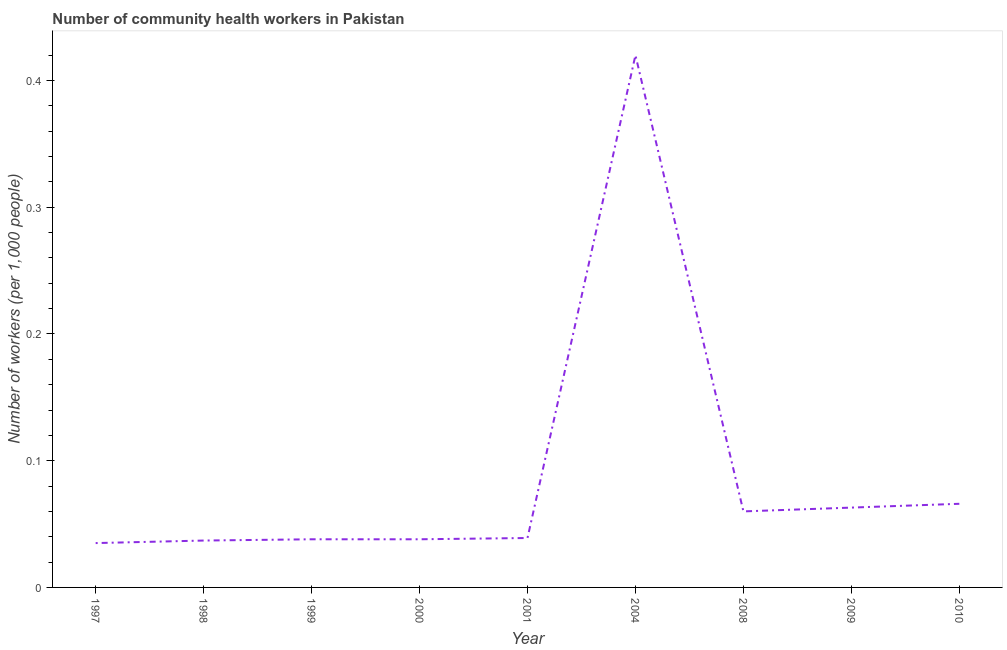What is the number of community health workers in 1998?
Provide a succinct answer. 0.04. Across all years, what is the maximum number of community health workers?
Your answer should be compact. 0.42. Across all years, what is the minimum number of community health workers?
Your answer should be very brief. 0.04. In which year was the number of community health workers minimum?
Your response must be concise. 1997. What is the sum of the number of community health workers?
Keep it short and to the point. 0.8. What is the difference between the number of community health workers in 2001 and 2004?
Make the answer very short. -0.38. What is the average number of community health workers per year?
Make the answer very short. 0.09. What is the median number of community health workers?
Your answer should be very brief. 0.04. Do a majority of the years between 1999 and 2008 (inclusive) have number of community health workers greater than 0.34 ?
Your response must be concise. No. What is the ratio of the number of community health workers in 1999 to that in 2009?
Your answer should be compact. 0.6. Is the number of community health workers in 2001 less than that in 2004?
Offer a terse response. Yes. What is the difference between the highest and the second highest number of community health workers?
Give a very brief answer. 0.35. What is the difference between the highest and the lowest number of community health workers?
Ensure brevity in your answer.  0.39. Does the number of community health workers monotonically increase over the years?
Your response must be concise. No. How many lines are there?
Provide a succinct answer. 1. What is the difference between two consecutive major ticks on the Y-axis?
Offer a very short reply. 0.1. What is the title of the graph?
Make the answer very short. Number of community health workers in Pakistan. What is the label or title of the Y-axis?
Ensure brevity in your answer.  Number of workers (per 1,0 people). What is the Number of workers (per 1,000 people) of 1997?
Offer a very short reply. 0.04. What is the Number of workers (per 1,000 people) in 1998?
Keep it short and to the point. 0.04. What is the Number of workers (per 1,000 people) in 1999?
Give a very brief answer. 0.04. What is the Number of workers (per 1,000 people) in 2000?
Your answer should be compact. 0.04. What is the Number of workers (per 1,000 people) in 2001?
Provide a short and direct response. 0.04. What is the Number of workers (per 1,000 people) in 2004?
Make the answer very short. 0.42. What is the Number of workers (per 1,000 people) of 2009?
Your response must be concise. 0.06. What is the Number of workers (per 1,000 people) of 2010?
Offer a very short reply. 0.07. What is the difference between the Number of workers (per 1,000 people) in 1997 and 1998?
Make the answer very short. -0. What is the difference between the Number of workers (per 1,000 people) in 1997 and 1999?
Give a very brief answer. -0. What is the difference between the Number of workers (per 1,000 people) in 1997 and 2000?
Provide a short and direct response. -0. What is the difference between the Number of workers (per 1,000 people) in 1997 and 2001?
Give a very brief answer. -0. What is the difference between the Number of workers (per 1,000 people) in 1997 and 2004?
Give a very brief answer. -0.39. What is the difference between the Number of workers (per 1,000 people) in 1997 and 2008?
Give a very brief answer. -0.03. What is the difference between the Number of workers (per 1,000 people) in 1997 and 2009?
Make the answer very short. -0.03. What is the difference between the Number of workers (per 1,000 people) in 1997 and 2010?
Keep it short and to the point. -0.03. What is the difference between the Number of workers (per 1,000 people) in 1998 and 1999?
Give a very brief answer. -0. What is the difference between the Number of workers (per 1,000 people) in 1998 and 2000?
Provide a succinct answer. -0. What is the difference between the Number of workers (per 1,000 people) in 1998 and 2001?
Offer a terse response. -0. What is the difference between the Number of workers (per 1,000 people) in 1998 and 2004?
Make the answer very short. -0.38. What is the difference between the Number of workers (per 1,000 people) in 1998 and 2008?
Offer a very short reply. -0.02. What is the difference between the Number of workers (per 1,000 people) in 1998 and 2009?
Your answer should be very brief. -0.03. What is the difference between the Number of workers (per 1,000 people) in 1998 and 2010?
Ensure brevity in your answer.  -0.03. What is the difference between the Number of workers (per 1,000 people) in 1999 and 2001?
Your answer should be compact. -0. What is the difference between the Number of workers (per 1,000 people) in 1999 and 2004?
Keep it short and to the point. -0.38. What is the difference between the Number of workers (per 1,000 people) in 1999 and 2008?
Provide a short and direct response. -0.02. What is the difference between the Number of workers (per 1,000 people) in 1999 and 2009?
Offer a very short reply. -0.03. What is the difference between the Number of workers (per 1,000 people) in 1999 and 2010?
Make the answer very short. -0.03. What is the difference between the Number of workers (per 1,000 people) in 2000 and 2001?
Keep it short and to the point. -0. What is the difference between the Number of workers (per 1,000 people) in 2000 and 2004?
Provide a short and direct response. -0.38. What is the difference between the Number of workers (per 1,000 people) in 2000 and 2008?
Provide a short and direct response. -0.02. What is the difference between the Number of workers (per 1,000 people) in 2000 and 2009?
Your response must be concise. -0.03. What is the difference between the Number of workers (per 1,000 people) in 2000 and 2010?
Keep it short and to the point. -0.03. What is the difference between the Number of workers (per 1,000 people) in 2001 and 2004?
Your answer should be very brief. -0.38. What is the difference between the Number of workers (per 1,000 people) in 2001 and 2008?
Offer a terse response. -0.02. What is the difference between the Number of workers (per 1,000 people) in 2001 and 2009?
Provide a succinct answer. -0.02. What is the difference between the Number of workers (per 1,000 people) in 2001 and 2010?
Make the answer very short. -0.03. What is the difference between the Number of workers (per 1,000 people) in 2004 and 2008?
Give a very brief answer. 0.36. What is the difference between the Number of workers (per 1,000 people) in 2004 and 2009?
Keep it short and to the point. 0.36. What is the difference between the Number of workers (per 1,000 people) in 2004 and 2010?
Offer a terse response. 0.35. What is the difference between the Number of workers (per 1,000 people) in 2008 and 2009?
Make the answer very short. -0. What is the difference between the Number of workers (per 1,000 people) in 2008 and 2010?
Your answer should be compact. -0.01. What is the difference between the Number of workers (per 1,000 people) in 2009 and 2010?
Provide a short and direct response. -0. What is the ratio of the Number of workers (per 1,000 people) in 1997 to that in 1998?
Offer a terse response. 0.95. What is the ratio of the Number of workers (per 1,000 people) in 1997 to that in 1999?
Keep it short and to the point. 0.92. What is the ratio of the Number of workers (per 1,000 people) in 1997 to that in 2000?
Your answer should be very brief. 0.92. What is the ratio of the Number of workers (per 1,000 people) in 1997 to that in 2001?
Provide a succinct answer. 0.9. What is the ratio of the Number of workers (per 1,000 people) in 1997 to that in 2004?
Make the answer very short. 0.08. What is the ratio of the Number of workers (per 1,000 people) in 1997 to that in 2008?
Your answer should be very brief. 0.58. What is the ratio of the Number of workers (per 1,000 people) in 1997 to that in 2009?
Make the answer very short. 0.56. What is the ratio of the Number of workers (per 1,000 people) in 1997 to that in 2010?
Your answer should be very brief. 0.53. What is the ratio of the Number of workers (per 1,000 people) in 1998 to that in 2000?
Give a very brief answer. 0.97. What is the ratio of the Number of workers (per 1,000 people) in 1998 to that in 2001?
Give a very brief answer. 0.95. What is the ratio of the Number of workers (per 1,000 people) in 1998 to that in 2004?
Offer a very short reply. 0.09. What is the ratio of the Number of workers (per 1,000 people) in 1998 to that in 2008?
Give a very brief answer. 0.62. What is the ratio of the Number of workers (per 1,000 people) in 1998 to that in 2009?
Your response must be concise. 0.59. What is the ratio of the Number of workers (per 1,000 people) in 1998 to that in 2010?
Ensure brevity in your answer.  0.56. What is the ratio of the Number of workers (per 1,000 people) in 1999 to that in 2000?
Provide a short and direct response. 1. What is the ratio of the Number of workers (per 1,000 people) in 1999 to that in 2001?
Offer a terse response. 0.97. What is the ratio of the Number of workers (per 1,000 people) in 1999 to that in 2004?
Make the answer very short. 0.09. What is the ratio of the Number of workers (per 1,000 people) in 1999 to that in 2008?
Offer a terse response. 0.63. What is the ratio of the Number of workers (per 1,000 people) in 1999 to that in 2009?
Give a very brief answer. 0.6. What is the ratio of the Number of workers (per 1,000 people) in 1999 to that in 2010?
Offer a terse response. 0.58. What is the ratio of the Number of workers (per 1,000 people) in 2000 to that in 2001?
Make the answer very short. 0.97. What is the ratio of the Number of workers (per 1,000 people) in 2000 to that in 2004?
Keep it short and to the point. 0.09. What is the ratio of the Number of workers (per 1,000 people) in 2000 to that in 2008?
Ensure brevity in your answer.  0.63. What is the ratio of the Number of workers (per 1,000 people) in 2000 to that in 2009?
Give a very brief answer. 0.6. What is the ratio of the Number of workers (per 1,000 people) in 2000 to that in 2010?
Your answer should be compact. 0.58. What is the ratio of the Number of workers (per 1,000 people) in 2001 to that in 2004?
Your answer should be very brief. 0.09. What is the ratio of the Number of workers (per 1,000 people) in 2001 to that in 2008?
Provide a short and direct response. 0.65. What is the ratio of the Number of workers (per 1,000 people) in 2001 to that in 2009?
Provide a succinct answer. 0.62. What is the ratio of the Number of workers (per 1,000 people) in 2001 to that in 2010?
Ensure brevity in your answer.  0.59. What is the ratio of the Number of workers (per 1,000 people) in 2004 to that in 2008?
Offer a very short reply. 7. What is the ratio of the Number of workers (per 1,000 people) in 2004 to that in 2009?
Offer a terse response. 6.67. What is the ratio of the Number of workers (per 1,000 people) in 2004 to that in 2010?
Your answer should be compact. 6.36. What is the ratio of the Number of workers (per 1,000 people) in 2008 to that in 2009?
Keep it short and to the point. 0.95. What is the ratio of the Number of workers (per 1,000 people) in 2008 to that in 2010?
Offer a terse response. 0.91. What is the ratio of the Number of workers (per 1,000 people) in 2009 to that in 2010?
Keep it short and to the point. 0.95. 